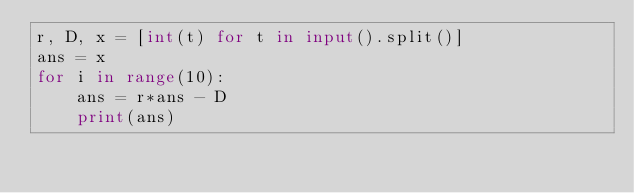<code> <loc_0><loc_0><loc_500><loc_500><_Python_>r, D, x = [int(t) for t in input().split()]
ans = x
for i in range(10):
    ans = r*ans - D
    print(ans)
</code> 